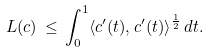<formula> <loc_0><loc_0><loc_500><loc_500>L ( c ) \, \leq \, \int _ { 0 } ^ { 1 } \langle c ^ { \prime } ( t ) , c ^ { \prime } ( t ) \rangle ^ { \frac { 1 } { 2 } } \, d t .</formula> 